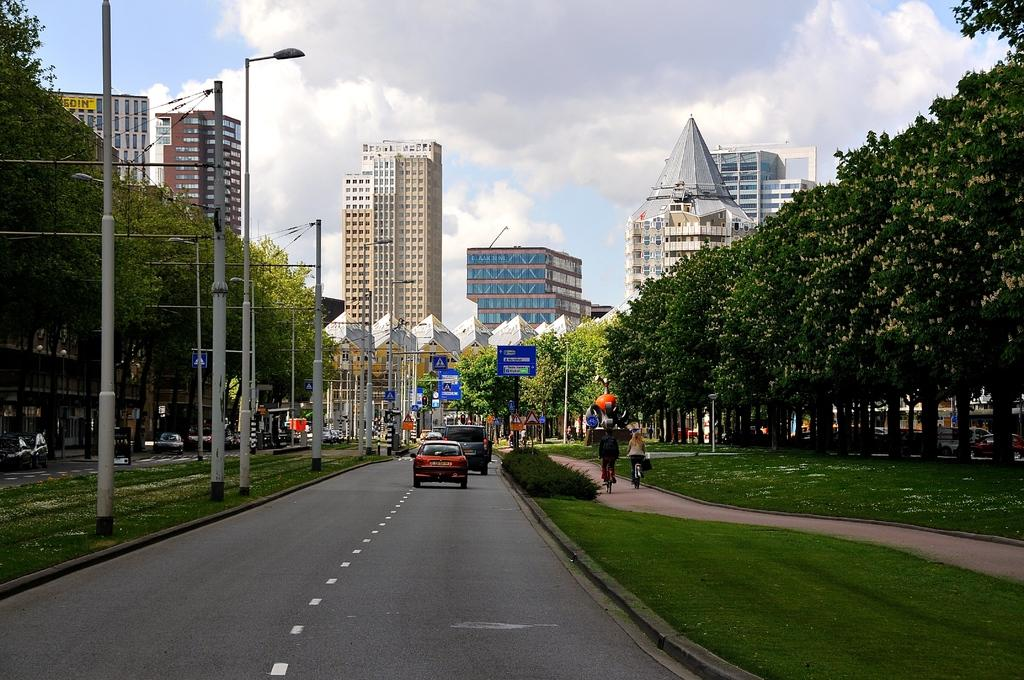What can be seen on the road in the image? There are vehicles on the road in the image. What objects are present in the image besides the vehicles? There are poles, boards, lights, buildings, plants, and trees in the image. What is visible in the background of the image? The sky is visible in the background of the image. Can you see a goat eating cherries in the image? There is no goat or cherries present in the image. Is there a bomb visible in the image? There is no bomb present in the image. 